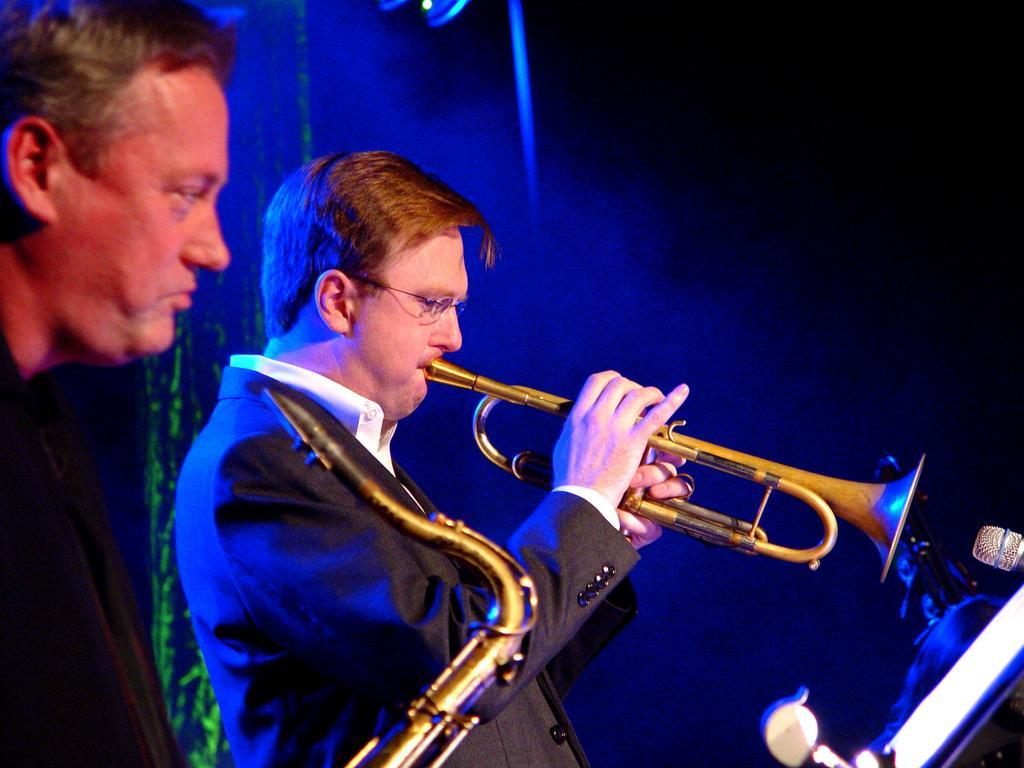Describe this image in one or two sentences. In this picture there is a man who is playing a saxophone. On the left there is another man who is wearing black dress and holding another saxophone. In front of them I can see the marks. In the back I can see the light beam. In the top right I can see the darkness. 